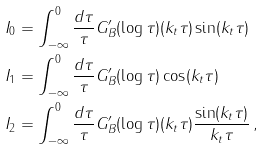Convert formula to latex. <formula><loc_0><loc_0><loc_500><loc_500>I _ { 0 } & = \int ^ { 0 } _ { - \infty } \frac { d \tau } { \tau } G ^ { \prime } _ { B } ( \log \tau ) ( k _ { t } \tau ) \sin ( k _ { t } \tau ) \\ I _ { 1 } & = \int ^ { 0 } _ { - \infty } \frac { d \tau } { \tau } G ^ { \prime } _ { B } ( \log \tau ) \cos ( k _ { t } \tau ) \\ I _ { 2 } & = \int ^ { 0 } _ { - \infty } \frac { d \tau } { \tau } G ^ { \prime } _ { B } ( \log \tau ) ( k _ { t } \tau ) \frac { \sin ( k _ { t } \tau ) } { k _ { t } \tau } \, ,</formula> 